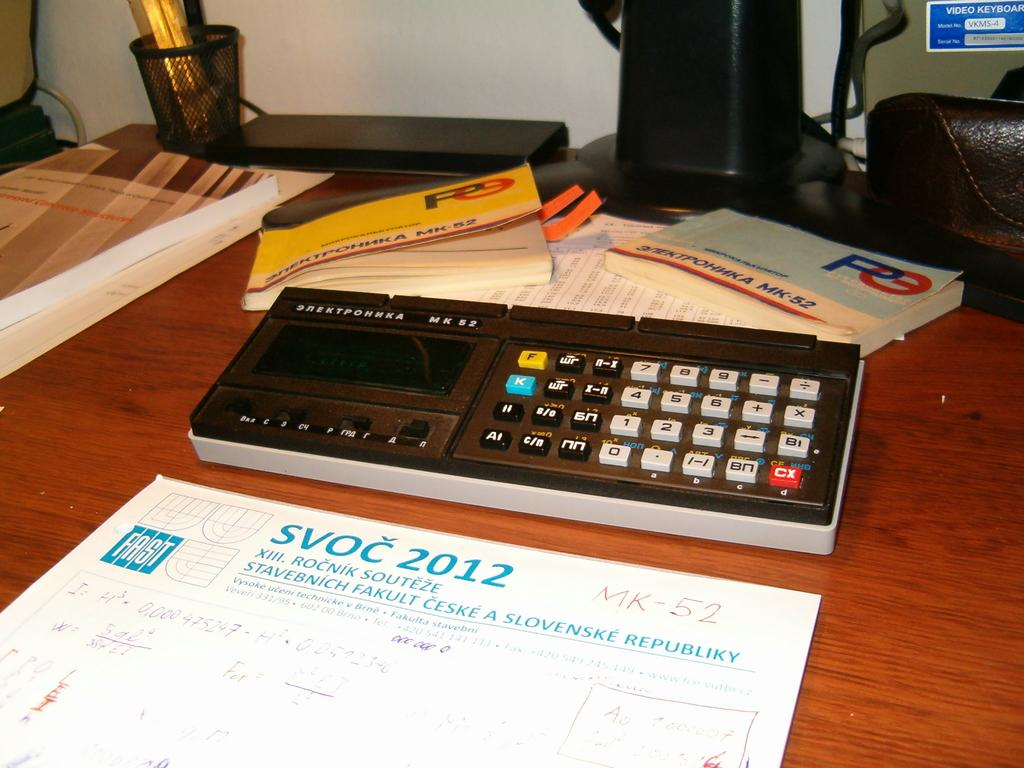<image>
Describe the image concisely. An SVOC 2012 paper in front of calculator on a desk. 